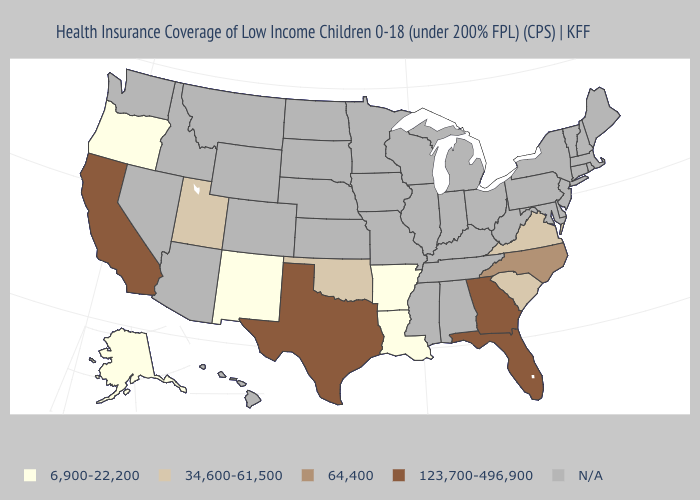Does Utah have the highest value in the USA?
Give a very brief answer. No. Which states have the lowest value in the USA?
Be succinct. Alaska, Arkansas, Louisiana, New Mexico, Oregon. Which states have the highest value in the USA?
Be succinct. California, Florida, Georgia, Texas. Which states hav the highest value in the South?
Be succinct. Florida, Georgia, Texas. What is the highest value in the USA?
Short answer required. 123,700-496,900. Among the states that border Colorado , which have the highest value?
Answer briefly. Oklahoma, Utah. What is the value of Florida?
Be succinct. 123,700-496,900. What is the lowest value in the West?
Quick response, please. 6,900-22,200. Is the legend a continuous bar?
Give a very brief answer. No. What is the value of North Dakota?
Short answer required. N/A. 